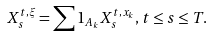<formula> <loc_0><loc_0><loc_500><loc_500>X ^ { t , \xi } _ { s } = \sum 1 _ { A _ { k } } X _ { s } ^ { t , x _ { k } } , t \leq s \leq T .</formula> 